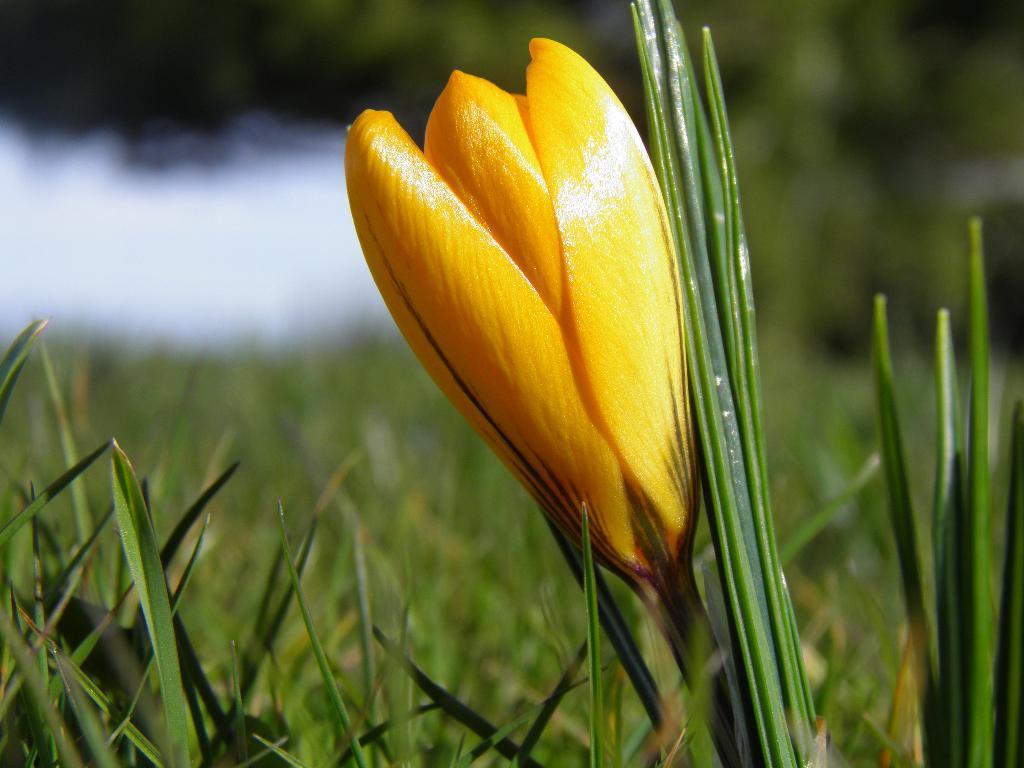Can you describe this image briefly? In the image there is some yellow flower to the plant and the background of the flower is blue. 